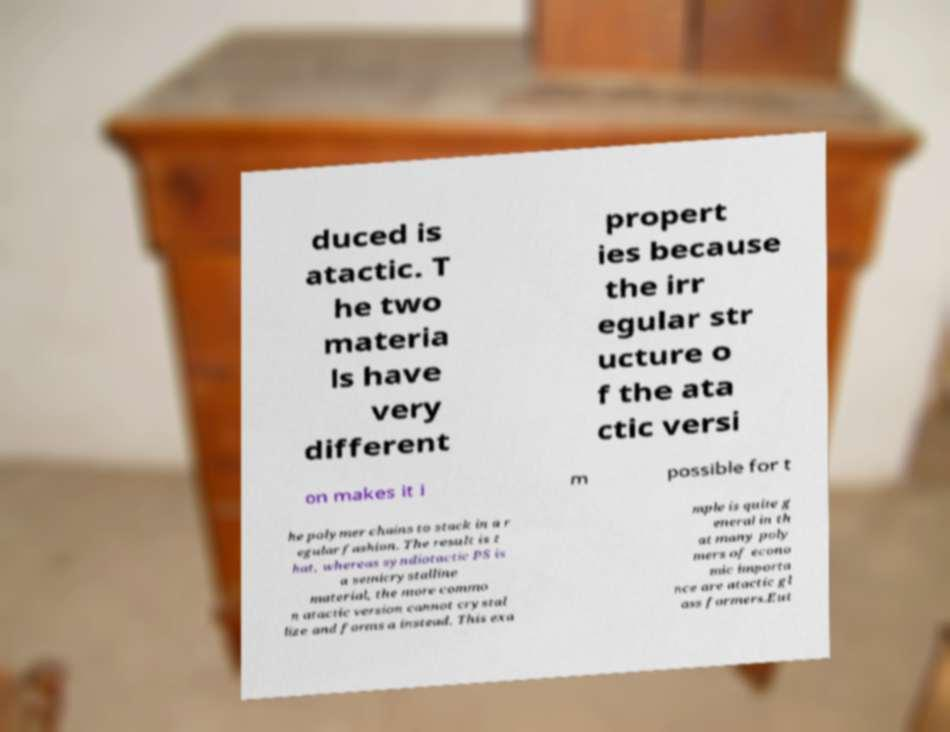Can you read and provide the text displayed in the image?This photo seems to have some interesting text. Can you extract and type it out for me? duced is atactic. T he two materia ls have very different propert ies because the irr egular str ucture o f the ata ctic versi on makes it i m possible for t he polymer chains to stack in a r egular fashion. The result is t hat, whereas syndiotactic PS is a semicrystalline material, the more commo n atactic version cannot crystal lize and forms a instead. This exa mple is quite g eneral in th at many poly mers of econo mic importa nce are atactic gl ass formers.Eut 